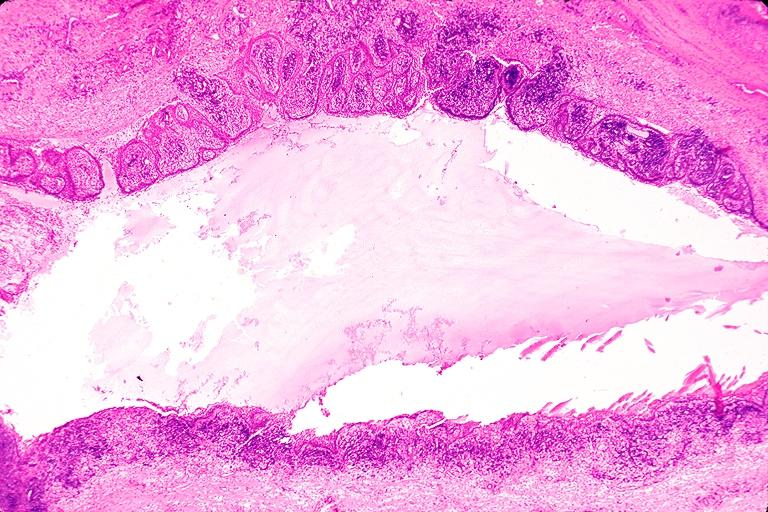s oral present?
Answer the question using a single word or phrase. Yes 